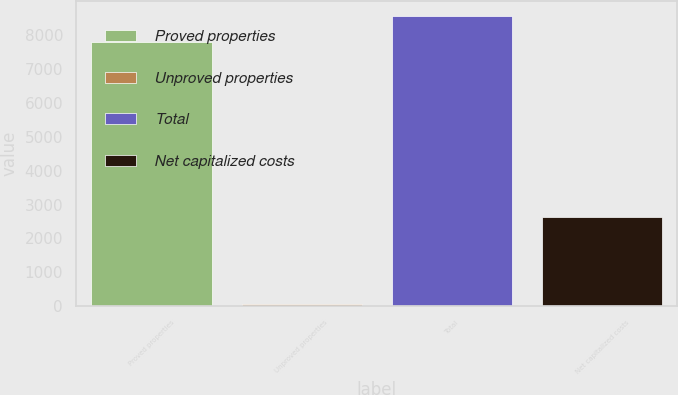Convert chart. <chart><loc_0><loc_0><loc_500><loc_500><bar_chart><fcel>Proved properties<fcel>Unproved properties<fcel>Total<fcel>Net capitalized costs<nl><fcel>7790<fcel>68<fcel>8569<fcel>2627<nl></chart> 